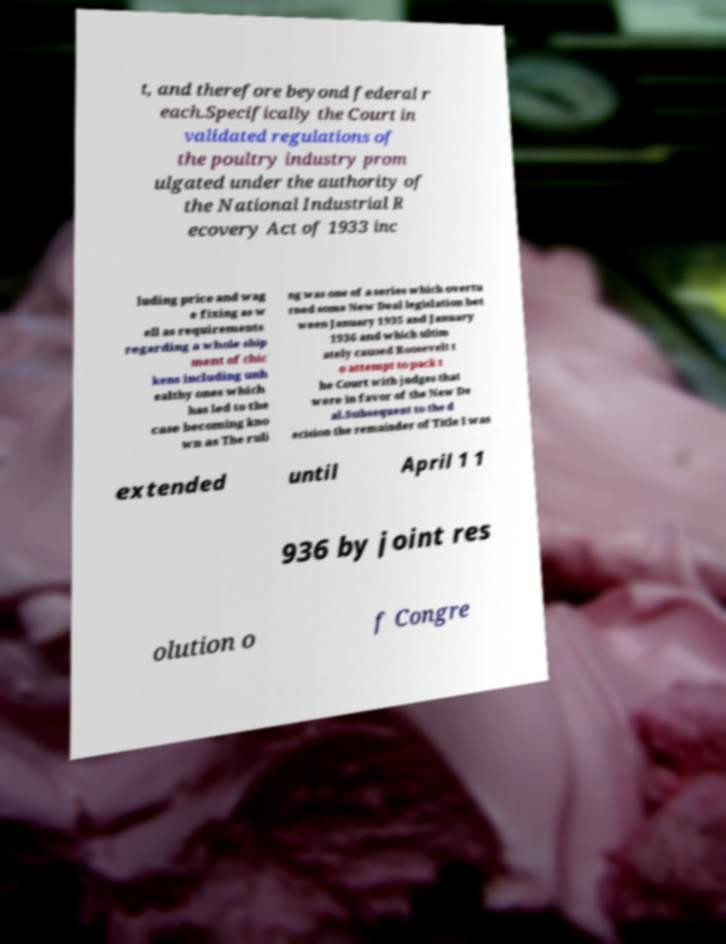Please identify and transcribe the text found in this image. t, and therefore beyond federal r each.Specifically the Court in validated regulations of the poultry industry prom ulgated under the authority of the National Industrial R ecovery Act of 1933 inc luding price and wag e fixing as w ell as requirements regarding a whole ship ment of chic kens including unh ealthy ones which has led to the case becoming kno wn as The ruli ng was one of a series which overtu rned some New Deal legislation bet ween January 1935 and January 1936 and which ultim ately caused Roosevelt t o attempt to pack t he Court with judges that were in favor of the New De al.Subsequent to the d ecision the remainder of Title I was extended until April 1 1 936 by joint res olution o f Congre 